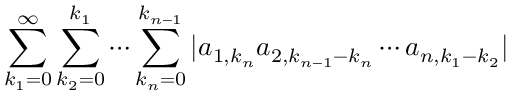Convert formula to latex. <formula><loc_0><loc_0><loc_500><loc_500>\sum _ { k _ { 1 } = 0 } ^ { \infty } \sum _ { k _ { 2 } = 0 } ^ { k _ { 1 } } \cdots \sum _ { k _ { n } = 0 } ^ { k _ { n - 1 } } | a _ { 1 , k _ { n } } a _ { 2 , k _ { n - 1 } - k _ { n } } \cdots a _ { n , k _ { 1 } - k _ { 2 } } |</formula> 